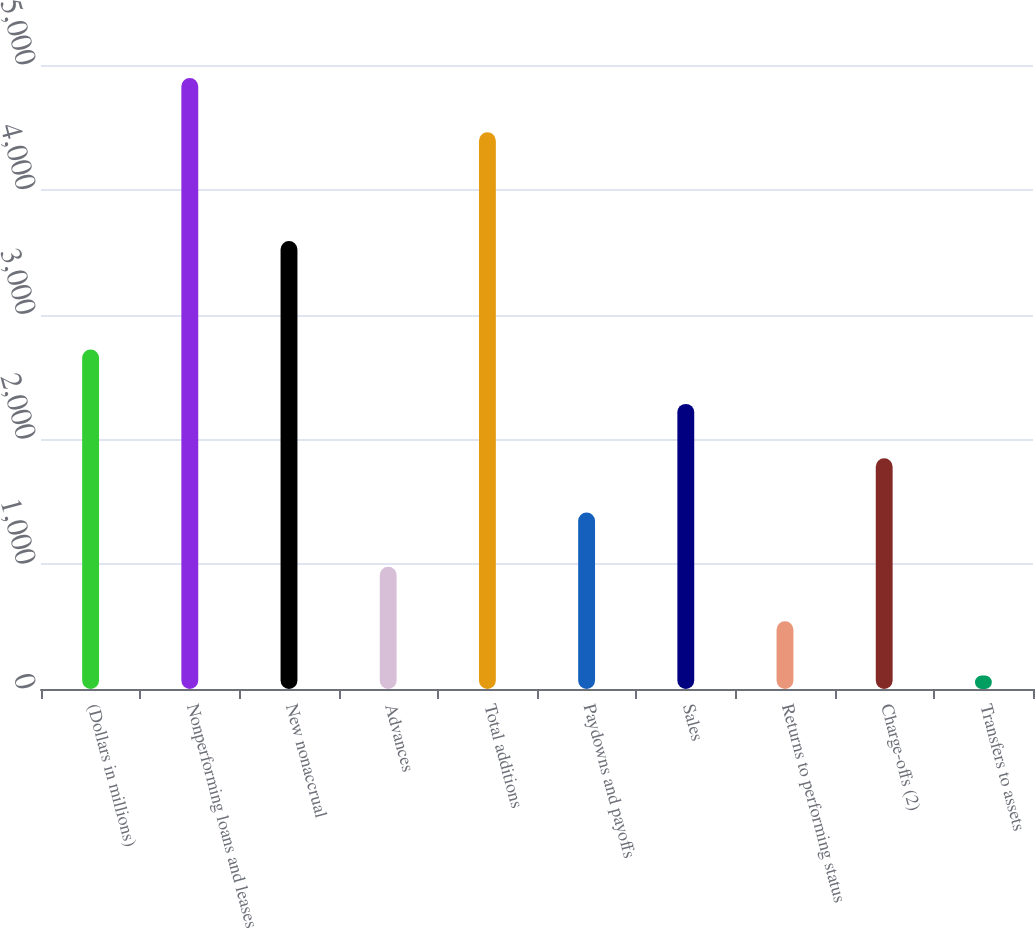Convert chart. <chart><loc_0><loc_0><loc_500><loc_500><bar_chart><fcel>(Dollars in millions)<fcel>Nonperforming loans and leases<fcel>New nonaccrual<fcel>Advances<fcel>Total additions<fcel>Paydowns and payoffs<fcel>Sales<fcel>Returns to performing status<fcel>Charge-offs (2)<fcel>Transfers to assets<nl><fcel>2719.8<fcel>4896.3<fcel>3590.4<fcel>978.6<fcel>4461<fcel>1413.9<fcel>2284.5<fcel>543.3<fcel>1849.2<fcel>108<nl></chart> 